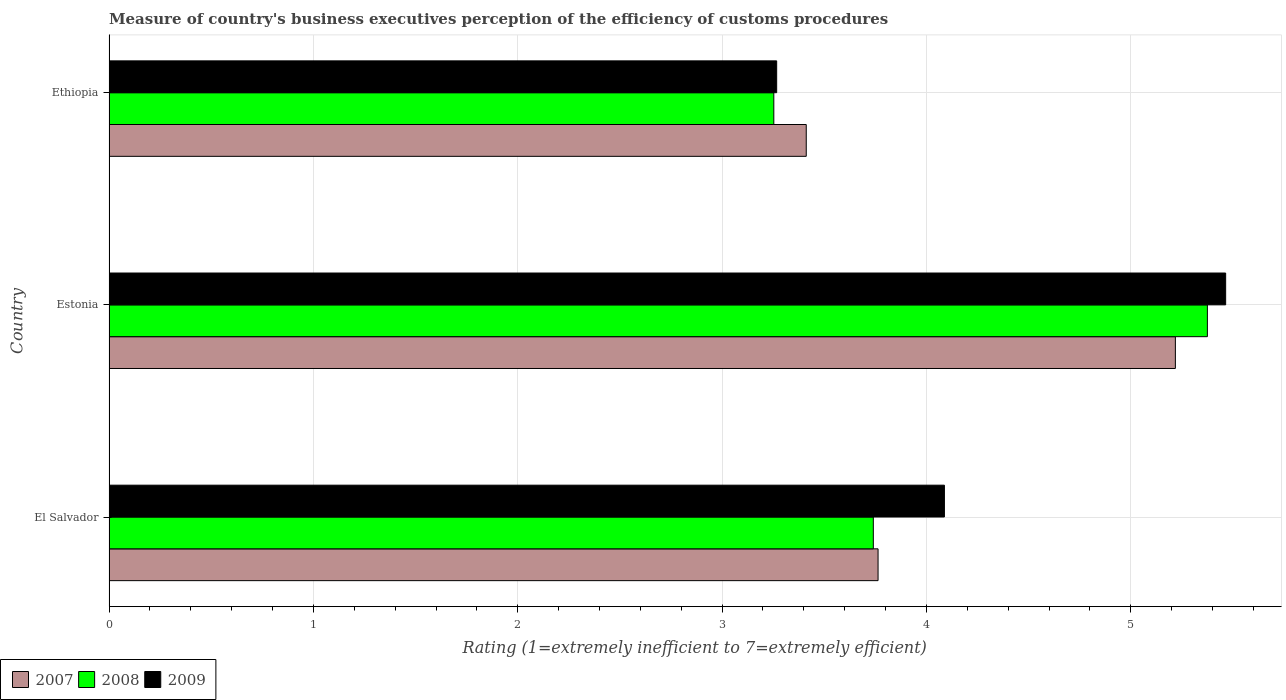How many groups of bars are there?
Offer a very short reply. 3. Are the number of bars per tick equal to the number of legend labels?
Offer a very short reply. Yes. Are the number of bars on each tick of the Y-axis equal?
Offer a very short reply. Yes. How many bars are there on the 2nd tick from the top?
Ensure brevity in your answer.  3. What is the label of the 1st group of bars from the top?
Offer a very short reply. Ethiopia. In how many cases, is the number of bars for a given country not equal to the number of legend labels?
Offer a very short reply. 0. What is the rating of the efficiency of customs procedure in 2008 in El Salvador?
Offer a very short reply. 3.74. Across all countries, what is the maximum rating of the efficiency of customs procedure in 2009?
Provide a short and direct response. 5.46. Across all countries, what is the minimum rating of the efficiency of customs procedure in 2008?
Offer a terse response. 3.25. In which country was the rating of the efficiency of customs procedure in 2008 maximum?
Your answer should be very brief. Estonia. In which country was the rating of the efficiency of customs procedure in 2007 minimum?
Offer a very short reply. Ethiopia. What is the total rating of the efficiency of customs procedure in 2008 in the graph?
Your response must be concise. 12.37. What is the difference between the rating of the efficiency of customs procedure in 2009 in Estonia and that in Ethiopia?
Your answer should be compact. 2.2. What is the difference between the rating of the efficiency of customs procedure in 2007 in Estonia and the rating of the efficiency of customs procedure in 2008 in Ethiopia?
Offer a terse response. 1.96. What is the average rating of the efficiency of customs procedure in 2008 per country?
Make the answer very short. 4.12. What is the difference between the rating of the efficiency of customs procedure in 2007 and rating of the efficiency of customs procedure in 2009 in Ethiopia?
Your answer should be very brief. 0.14. What is the ratio of the rating of the efficiency of customs procedure in 2009 in El Salvador to that in Ethiopia?
Offer a very short reply. 1.25. What is the difference between the highest and the second highest rating of the efficiency of customs procedure in 2009?
Keep it short and to the point. 1.38. What is the difference between the highest and the lowest rating of the efficiency of customs procedure in 2008?
Your answer should be compact. 2.12. Is the sum of the rating of the efficiency of customs procedure in 2007 in El Salvador and Ethiopia greater than the maximum rating of the efficiency of customs procedure in 2009 across all countries?
Your response must be concise. Yes. What does the 2nd bar from the bottom in El Salvador represents?
Offer a terse response. 2008. Is it the case that in every country, the sum of the rating of the efficiency of customs procedure in 2007 and rating of the efficiency of customs procedure in 2008 is greater than the rating of the efficiency of customs procedure in 2009?
Keep it short and to the point. Yes. How many bars are there?
Offer a very short reply. 9. What is the difference between two consecutive major ticks on the X-axis?
Your answer should be very brief. 1. Does the graph contain any zero values?
Provide a short and direct response. No. Does the graph contain grids?
Your answer should be very brief. Yes. Where does the legend appear in the graph?
Offer a very short reply. Bottom left. How are the legend labels stacked?
Ensure brevity in your answer.  Horizontal. What is the title of the graph?
Provide a short and direct response. Measure of country's business executives perception of the efficiency of customs procedures. Does "2006" appear as one of the legend labels in the graph?
Keep it short and to the point. No. What is the label or title of the X-axis?
Offer a very short reply. Rating (1=extremely inefficient to 7=extremely efficient). What is the Rating (1=extremely inefficient to 7=extremely efficient) of 2007 in El Salvador?
Your response must be concise. 3.76. What is the Rating (1=extremely inefficient to 7=extremely efficient) in 2008 in El Salvador?
Give a very brief answer. 3.74. What is the Rating (1=extremely inefficient to 7=extremely efficient) of 2009 in El Salvador?
Provide a succinct answer. 4.09. What is the Rating (1=extremely inefficient to 7=extremely efficient) of 2007 in Estonia?
Keep it short and to the point. 5.22. What is the Rating (1=extremely inefficient to 7=extremely efficient) of 2008 in Estonia?
Provide a short and direct response. 5.37. What is the Rating (1=extremely inefficient to 7=extremely efficient) of 2009 in Estonia?
Provide a short and direct response. 5.46. What is the Rating (1=extremely inefficient to 7=extremely efficient) in 2007 in Ethiopia?
Your response must be concise. 3.41. What is the Rating (1=extremely inefficient to 7=extremely efficient) of 2008 in Ethiopia?
Make the answer very short. 3.25. What is the Rating (1=extremely inefficient to 7=extremely efficient) in 2009 in Ethiopia?
Ensure brevity in your answer.  3.27. Across all countries, what is the maximum Rating (1=extremely inefficient to 7=extremely efficient) of 2007?
Give a very brief answer. 5.22. Across all countries, what is the maximum Rating (1=extremely inefficient to 7=extremely efficient) of 2008?
Your answer should be compact. 5.37. Across all countries, what is the maximum Rating (1=extremely inefficient to 7=extremely efficient) of 2009?
Keep it short and to the point. 5.46. Across all countries, what is the minimum Rating (1=extremely inefficient to 7=extremely efficient) of 2007?
Provide a short and direct response. 3.41. Across all countries, what is the minimum Rating (1=extremely inefficient to 7=extremely efficient) in 2008?
Give a very brief answer. 3.25. Across all countries, what is the minimum Rating (1=extremely inefficient to 7=extremely efficient) of 2009?
Make the answer very short. 3.27. What is the total Rating (1=extremely inefficient to 7=extremely efficient) in 2007 in the graph?
Ensure brevity in your answer.  12.39. What is the total Rating (1=extremely inefficient to 7=extremely efficient) in 2008 in the graph?
Give a very brief answer. 12.37. What is the total Rating (1=extremely inefficient to 7=extremely efficient) in 2009 in the graph?
Your answer should be very brief. 12.82. What is the difference between the Rating (1=extremely inefficient to 7=extremely efficient) in 2007 in El Salvador and that in Estonia?
Provide a succinct answer. -1.45. What is the difference between the Rating (1=extremely inefficient to 7=extremely efficient) in 2008 in El Salvador and that in Estonia?
Keep it short and to the point. -1.63. What is the difference between the Rating (1=extremely inefficient to 7=extremely efficient) of 2009 in El Salvador and that in Estonia?
Keep it short and to the point. -1.38. What is the difference between the Rating (1=extremely inefficient to 7=extremely efficient) of 2007 in El Salvador and that in Ethiopia?
Make the answer very short. 0.35. What is the difference between the Rating (1=extremely inefficient to 7=extremely efficient) in 2008 in El Salvador and that in Ethiopia?
Provide a succinct answer. 0.49. What is the difference between the Rating (1=extremely inefficient to 7=extremely efficient) of 2009 in El Salvador and that in Ethiopia?
Make the answer very short. 0.82. What is the difference between the Rating (1=extremely inefficient to 7=extremely efficient) in 2007 in Estonia and that in Ethiopia?
Your answer should be compact. 1.81. What is the difference between the Rating (1=extremely inefficient to 7=extremely efficient) in 2008 in Estonia and that in Ethiopia?
Give a very brief answer. 2.12. What is the difference between the Rating (1=extremely inefficient to 7=extremely efficient) of 2009 in Estonia and that in Ethiopia?
Ensure brevity in your answer.  2.2. What is the difference between the Rating (1=extremely inefficient to 7=extremely efficient) of 2007 in El Salvador and the Rating (1=extremely inefficient to 7=extremely efficient) of 2008 in Estonia?
Give a very brief answer. -1.61. What is the difference between the Rating (1=extremely inefficient to 7=extremely efficient) in 2007 in El Salvador and the Rating (1=extremely inefficient to 7=extremely efficient) in 2009 in Estonia?
Keep it short and to the point. -1.7. What is the difference between the Rating (1=extremely inefficient to 7=extremely efficient) in 2008 in El Salvador and the Rating (1=extremely inefficient to 7=extremely efficient) in 2009 in Estonia?
Provide a succinct answer. -1.72. What is the difference between the Rating (1=extremely inefficient to 7=extremely efficient) of 2007 in El Salvador and the Rating (1=extremely inefficient to 7=extremely efficient) of 2008 in Ethiopia?
Provide a succinct answer. 0.51. What is the difference between the Rating (1=extremely inefficient to 7=extremely efficient) of 2007 in El Salvador and the Rating (1=extremely inefficient to 7=extremely efficient) of 2009 in Ethiopia?
Provide a short and direct response. 0.5. What is the difference between the Rating (1=extremely inefficient to 7=extremely efficient) in 2008 in El Salvador and the Rating (1=extremely inefficient to 7=extremely efficient) in 2009 in Ethiopia?
Your answer should be compact. 0.47. What is the difference between the Rating (1=extremely inefficient to 7=extremely efficient) in 2007 in Estonia and the Rating (1=extremely inefficient to 7=extremely efficient) in 2008 in Ethiopia?
Keep it short and to the point. 1.96. What is the difference between the Rating (1=extremely inefficient to 7=extremely efficient) of 2007 in Estonia and the Rating (1=extremely inefficient to 7=extremely efficient) of 2009 in Ethiopia?
Provide a short and direct response. 1.95. What is the difference between the Rating (1=extremely inefficient to 7=extremely efficient) in 2008 in Estonia and the Rating (1=extremely inefficient to 7=extremely efficient) in 2009 in Ethiopia?
Your answer should be compact. 2.11. What is the average Rating (1=extremely inefficient to 7=extremely efficient) in 2007 per country?
Provide a short and direct response. 4.13. What is the average Rating (1=extremely inefficient to 7=extremely efficient) of 2008 per country?
Keep it short and to the point. 4.12. What is the average Rating (1=extremely inefficient to 7=extremely efficient) in 2009 per country?
Provide a short and direct response. 4.27. What is the difference between the Rating (1=extremely inefficient to 7=extremely efficient) in 2007 and Rating (1=extremely inefficient to 7=extremely efficient) in 2008 in El Salvador?
Your response must be concise. 0.02. What is the difference between the Rating (1=extremely inefficient to 7=extremely efficient) of 2007 and Rating (1=extremely inefficient to 7=extremely efficient) of 2009 in El Salvador?
Your answer should be compact. -0.32. What is the difference between the Rating (1=extremely inefficient to 7=extremely efficient) of 2008 and Rating (1=extremely inefficient to 7=extremely efficient) of 2009 in El Salvador?
Your answer should be compact. -0.35. What is the difference between the Rating (1=extremely inefficient to 7=extremely efficient) of 2007 and Rating (1=extremely inefficient to 7=extremely efficient) of 2008 in Estonia?
Provide a succinct answer. -0.16. What is the difference between the Rating (1=extremely inefficient to 7=extremely efficient) of 2007 and Rating (1=extremely inefficient to 7=extremely efficient) of 2009 in Estonia?
Make the answer very short. -0.25. What is the difference between the Rating (1=extremely inefficient to 7=extremely efficient) in 2008 and Rating (1=extremely inefficient to 7=extremely efficient) in 2009 in Estonia?
Provide a succinct answer. -0.09. What is the difference between the Rating (1=extremely inefficient to 7=extremely efficient) in 2007 and Rating (1=extremely inefficient to 7=extremely efficient) in 2008 in Ethiopia?
Your answer should be compact. 0.16. What is the difference between the Rating (1=extremely inefficient to 7=extremely efficient) of 2007 and Rating (1=extremely inefficient to 7=extremely efficient) of 2009 in Ethiopia?
Give a very brief answer. 0.14. What is the difference between the Rating (1=extremely inefficient to 7=extremely efficient) in 2008 and Rating (1=extremely inefficient to 7=extremely efficient) in 2009 in Ethiopia?
Ensure brevity in your answer.  -0.01. What is the ratio of the Rating (1=extremely inefficient to 7=extremely efficient) in 2007 in El Salvador to that in Estonia?
Your response must be concise. 0.72. What is the ratio of the Rating (1=extremely inefficient to 7=extremely efficient) in 2008 in El Salvador to that in Estonia?
Your answer should be very brief. 0.7. What is the ratio of the Rating (1=extremely inefficient to 7=extremely efficient) of 2009 in El Salvador to that in Estonia?
Offer a terse response. 0.75. What is the ratio of the Rating (1=extremely inefficient to 7=extremely efficient) in 2007 in El Salvador to that in Ethiopia?
Make the answer very short. 1.1. What is the ratio of the Rating (1=extremely inefficient to 7=extremely efficient) of 2008 in El Salvador to that in Ethiopia?
Offer a terse response. 1.15. What is the ratio of the Rating (1=extremely inefficient to 7=extremely efficient) of 2009 in El Salvador to that in Ethiopia?
Make the answer very short. 1.25. What is the ratio of the Rating (1=extremely inefficient to 7=extremely efficient) in 2007 in Estonia to that in Ethiopia?
Offer a terse response. 1.53. What is the ratio of the Rating (1=extremely inefficient to 7=extremely efficient) in 2008 in Estonia to that in Ethiopia?
Provide a short and direct response. 1.65. What is the ratio of the Rating (1=extremely inefficient to 7=extremely efficient) in 2009 in Estonia to that in Ethiopia?
Ensure brevity in your answer.  1.67. What is the difference between the highest and the second highest Rating (1=extremely inefficient to 7=extremely efficient) in 2007?
Provide a succinct answer. 1.45. What is the difference between the highest and the second highest Rating (1=extremely inefficient to 7=extremely efficient) of 2008?
Give a very brief answer. 1.63. What is the difference between the highest and the second highest Rating (1=extremely inefficient to 7=extremely efficient) of 2009?
Give a very brief answer. 1.38. What is the difference between the highest and the lowest Rating (1=extremely inefficient to 7=extremely efficient) of 2007?
Provide a succinct answer. 1.81. What is the difference between the highest and the lowest Rating (1=extremely inefficient to 7=extremely efficient) of 2008?
Give a very brief answer. 2.12. What is the difference between the highest and the lowest Rating (1=extremely inefficient to 7=extremely efficient) in 2009?
Your response must be concise. 2.2. 